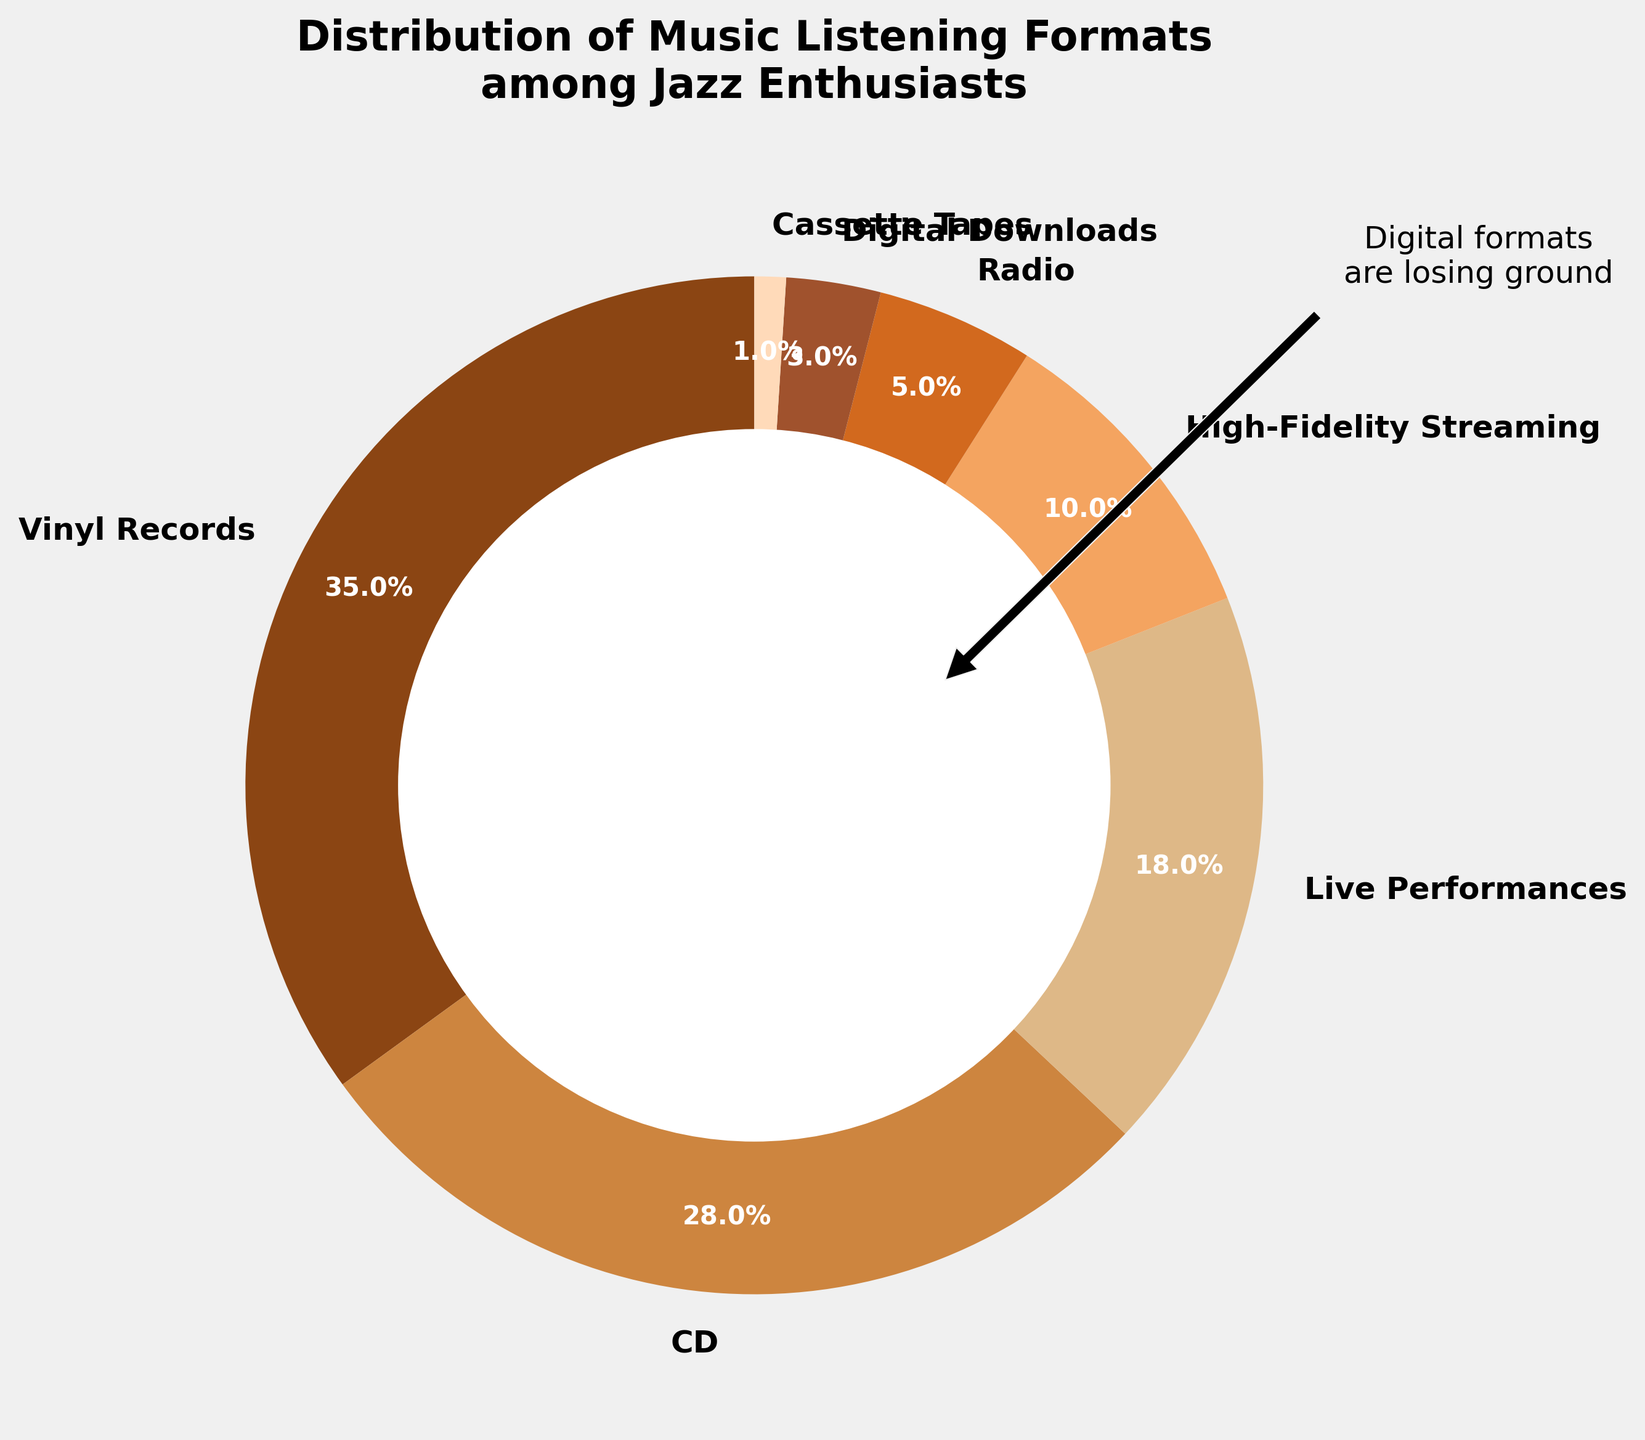What's the sum of the percentages for Vinyl Records and CD formats? The percentage for Vinyl Records is 35%, and the percentage for CD formats is 28%. Adding them together gives 35 + 28 = 63.
Answer: 63% Which format has a higher percentage, Live Performances or High-Fidelity Streaming? Live Performances account for 18%, whereas High-Fidelity Streaming is 10%. Comparing these values, 18% is greater than 10%.
Answer: Live Performances What is the difference between the percentages of Vinyl Records and Digital Downloads? Vinyl Records hold 35% while Digital Downloads are at 3%. Calculating the difference: 35 - 3 = 32.
Answer: 32% How many formats have a percentage less than 10%? The formats with percentages less than 10% are High-Fidelity Streaming (10%), Radio (5%), Digital Downloads (3%), and Cassette Tapes (1%). Counting these formats gives 4.
Answer: 4 Which format is represented by the darkest color in the pie chart? The pie chart uses varying shades of brown, ranging from dark to light. The darkest shade represents Vinyl Records, which holds the largest percentage (35%).
Answer: Vinyl Records If you combine the percentages of all digital formats (High-Fidelity Streaming, Digital Downloads), what is the total? High-Fidelity Streaming accounts for 10%, and Digital Downloads account for 3%. Adding them together: 10 + 3 = 13.
Answer: 13% Which format's wedge is visually the smallest in the pie chart? Cassette Tapes have the smallest percentage at 1%, making it the smallest wedge in the pie chart.
Answer: Cassette Tapes Which non-digital format has the second highest percentage? Among non-digital formats, Vinyl Records has the highest at 35%, followed by CDs at 28%. Therefore, CDs have the second highest percentage.
Answer: CDs What's the combined percentage of Radio and Live Performances? Radio accounts for 5%, and Live Performances account for 18%. Adding these together: 5 + 18 = 23.
Answer: 23% What visual annotation is included in the pie chart, and what does it refer to? The pie chart includes an annotation that says "Digital formats are losing ground," which refers to the smaller percentages held by digital formats such as High-Fidelity Streaming and Digital Downloads.
Answer: Digital formats are losing ground 